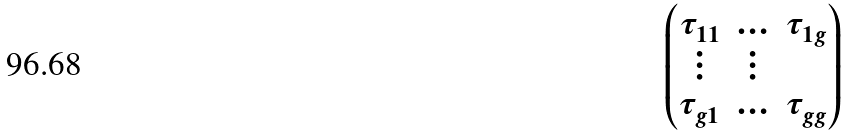Convert formula to latex. <formula><loc_0><loc_0><loc_500><loc_500>\begin{pmatrix} { \tau _ { 1 1 } } & { \hdots } & { \tau _ { 1 g } } \\ { \vdots } & { \vdots } \\ { \tau _ { g 1 } } & { \hdots } & { \tau _ { g g } } \end{pmatrix}</formula> 